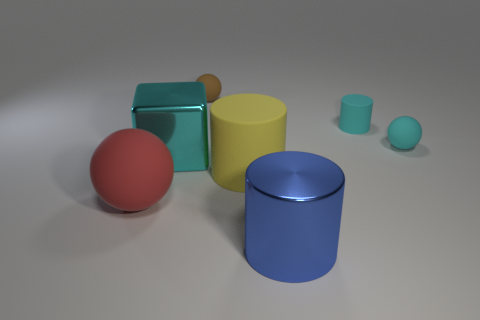Are there the same number of big cyan things behind the cyan cylinder and large things?
Keep it short and to the point. No. How many things are tiny red rubber objects or small cyan rubber balls?
Offer a terse response. 1. Is there anything else that is the same shape as the large blue metallic object?
Your answer should be very brief. Yes. What is the shape of the small brown matte object behind the big metallic block that is on the right side of the red sphere?
Your answer should be compact. Sphere. What shape is the brown object that is made of the same material as the large yellow thing?
Offer a terse response. Sphere. What size is the ball that is right of the large cylinder behind the big red rubber object?
Offer a very short reply. Small. The large red thing is what shape?
Keep it short and to the point. Sphere. What number of large things are cyan metal blocks or yellow cylinders?
Keep it short and to the point. 2. What size is the brown rubber object that is the same shape as the big red object?
Keep it short and to the point. Small. What number of rubber things are both in front of the cyan metal cube and to the right of the shiny cube?
Your answer should be compact. 1. 